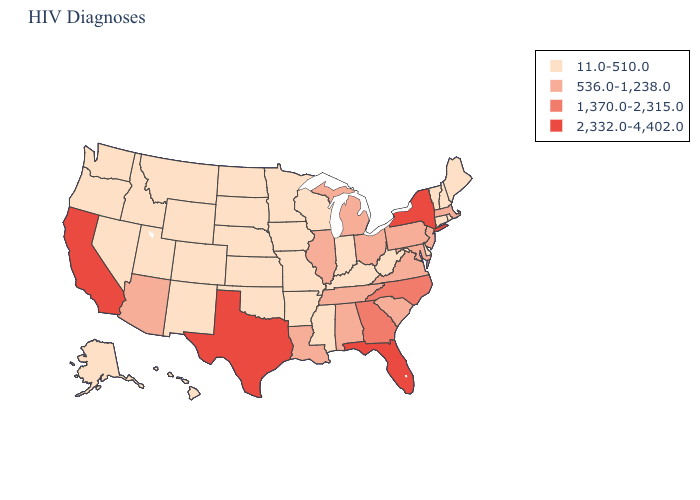Does Wyoming have the same value as Kansas?
Be succinct. Yes. What is the value of Minnesota?
Be succinct. 11.0-510.0. Is the legend a continuous bar?
Be succinct. No. What is the lowest value in states that border California?
Give a very brief answer. 11.0-510.0. Name the states that have a value in the range 1,370.0-2,315.0?
Quick response, please. Georgia, North Carolina. What is the lowest value in the Northeast?
Write a very short answer. 11.0-510.0. Name the states that have a value in the range 2,332.0-4,402.0?
Write a very short answer. California, Florida, New York, Texas. Does Illinois have the highest value in the MidWest?
Give a very brief answer. Yes. Name the states that have a value in the range 2,332.0-4,402.0?
Keep it brief. California, Florida, New York, Texas. Name the states that have a value in the range 1,370.0-2,315.0?
Short answer required. Georgia, North Carolina. Among the states that border Louisiana , which have the highest value?
Keep it brief. Texas. Name the states that have a value in the range 11.0-510.0?
Keep it brief. Alaska, Arkansas, Colorado, Connecticut, Delaware, Hawaii, Idaho, Indiana, Iowa, Kansas, Kentucky, Maine, Minnesota, Mississippi, Missouri, Montana, Nebraska, Nevada, New Hampshire, New Mexico, North Dakota, Oklahoma, Oregon, Rhode Island, South Dakota, Utah, Vermont, Washington, West Virginia, Wisconsin, Wyoming. Does Delaware have the lowest value in the South?
Give a very brief answer. Yes. Among the states that border Michigan , does Ohio have the highest value?
Keep it brief. Yes. Among the states that border California , which have the highest value?
Answer briefly. Arizona. 